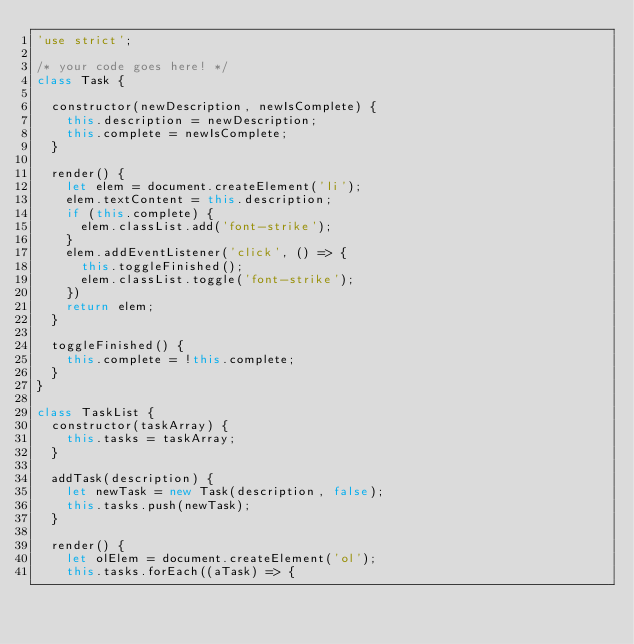Convert code to text. <code><loc_0><loc_0><loc_500><loc_500><_JavaScript_>'use strict';

/* your code goes here! */
class Task {

  constructor(newDescription, newIsComplete) {
    this.description = newDescription;
    this.complete = newIsComplete;
  }

  render() {
    let elem = document.createElement('li');
    elem.textContent = this.description;
    if (this.complete) {
      elem.classList.add('font-strike');
    }
    elem.addEventListener('click', () => {
      this.toggleFinished();
      elem.classList.toggle('font-strike');
    })
    return elem;
  }

  toggleFinished() {
    this.complete = !this.complete;
  }
}

class TaskList {
  constructor(taskArray) {
    this.tasks = taskArray;
  }

  addTask(description) {
    let newTask = new Task(description, false);
    this.tasks.push(newTask);
  }

  render() {
    let olElem = document.createElement('ol');
    this.tasks.forEach((aTask) => {</code> 